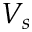<formula> <loc_0><loc_0><loc_500><loc_500>V _ { s }</formula> 